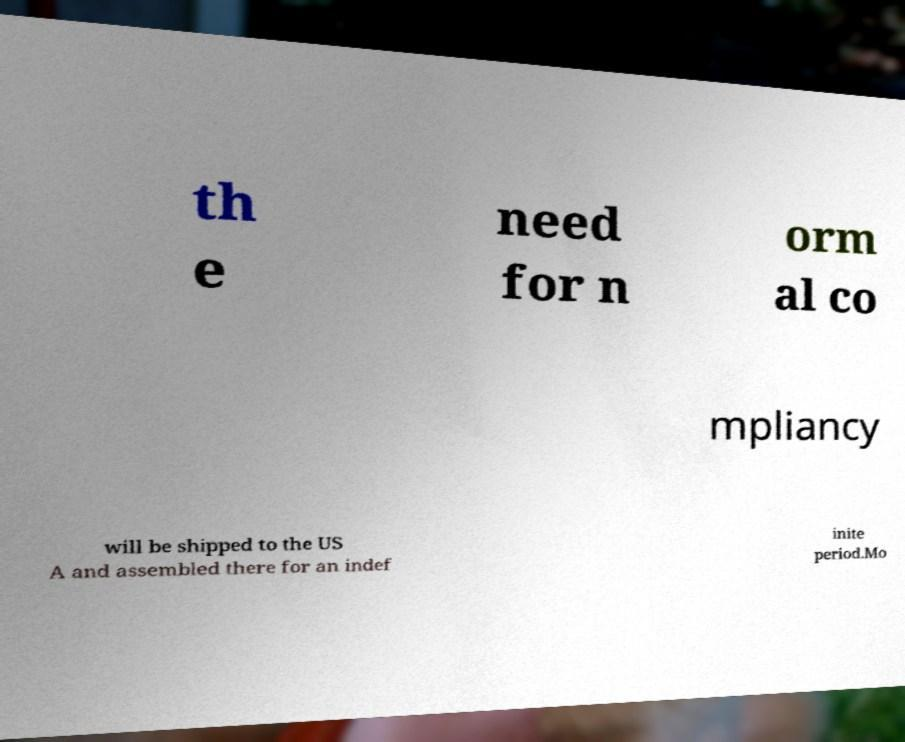I need the written content from this picture converted into text. Can you do that? th e need for n orm al co mpliancy will be shipped to the US A and assembled there for an indef inite period.Mo 